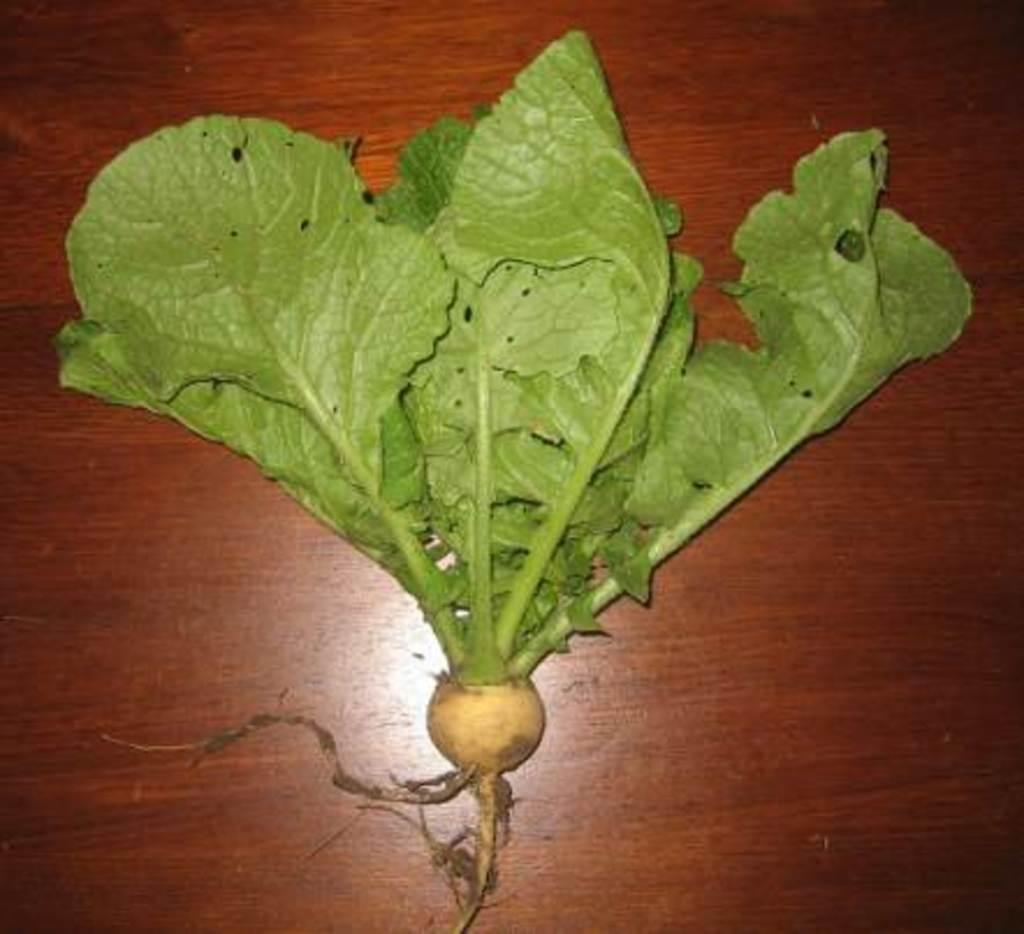What piece of furniture is present in the image? There is a table in the image. What is placed on the table? There is a radish on the table. What scientific experiment is being conducted with the radish in the image? There is no scientific experiment being conducted with the radish in the image; it is simply a radish placed on a table. 